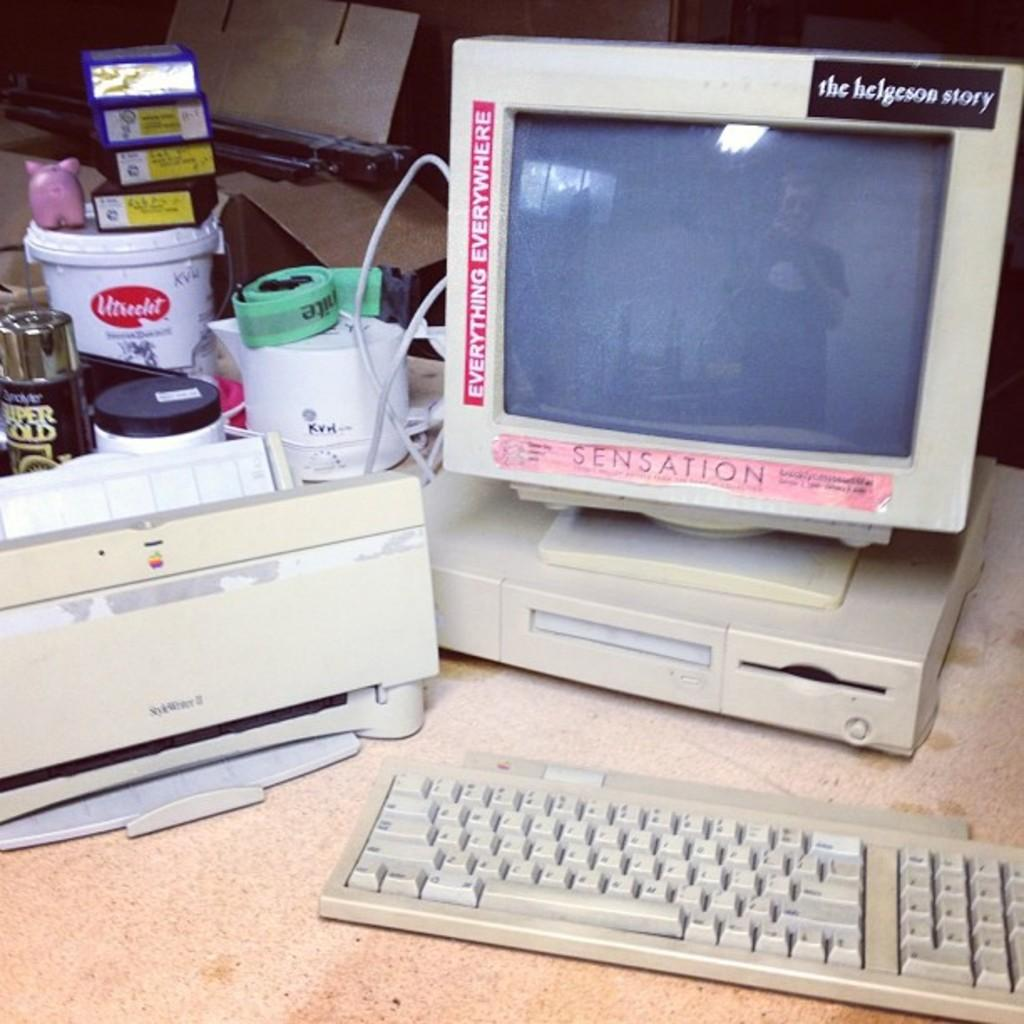<image>
Describe the image concisely. the word helgeson on top of a computer 